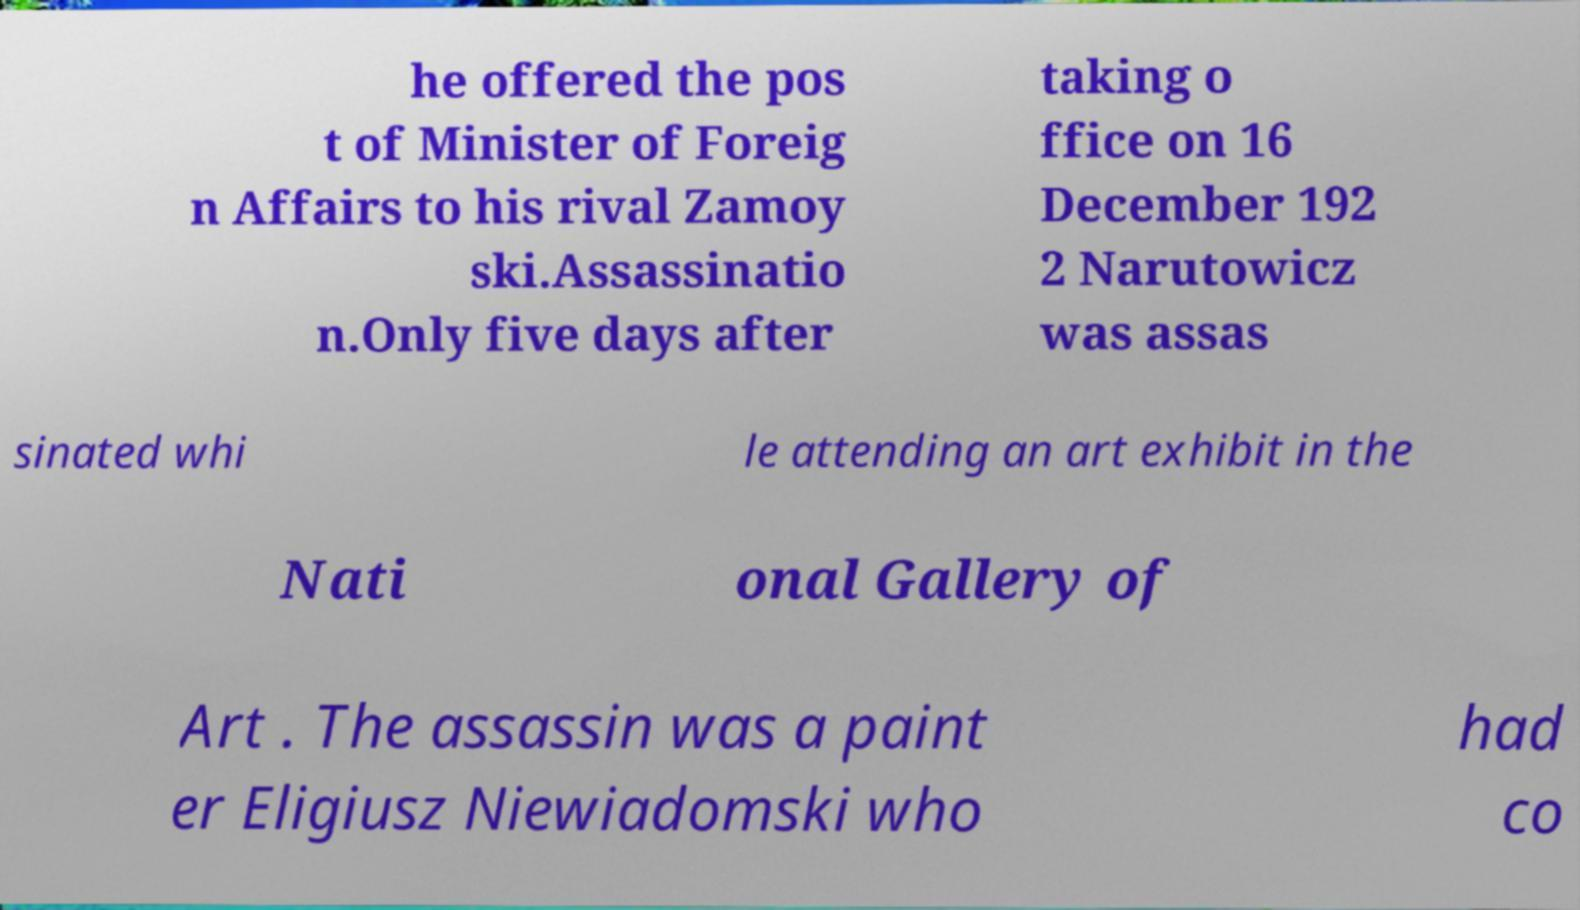Could you extract and type out the text from this image? he offered the pos t of Minister of Foreig n Affairs to his rival Zamoy ski.Assassinatio n.Only five days after taking o ffice on 16 December 192 2 Narutowicz was assas sinated whi le attending an art exhibit in the Nati onal Gallery of Art . The assassin was a paint er Eligiusz Niewiadomski who had co 